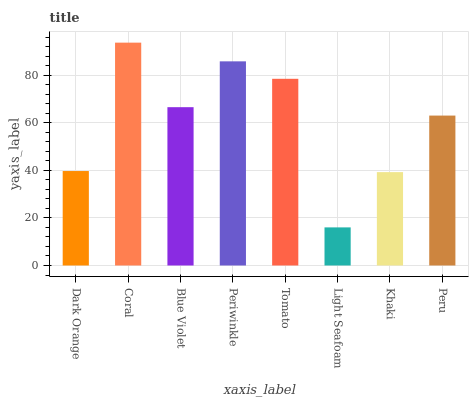Is Light Seafoam the minimum?
Answer yes or no. Yes. Is Coral the maximum?
Answer yes or no. Yes. Is Blue Violet the minimum?
Answer yes or no. No. Is Blue Violet the maximum?
Answer yes or no. No. Is Coral greater than Blue Violet?
Answer yes or no. Yes. Is Blue Violet less than Coral?
Answer yes or no. Yes. Is Blue Violet greater than Coral?
Answer yes or no. No. Is Coral less than Blue Violet?
Answer yes or no. No. Is Blue Violet the high median?
Answer yes or no. Yes. Is Peru the low median?
Answer yes or no. Yes. Is Khaki the high median?
Answer yes or no. No. Is Coral the low median?
Answer yes or no. No. 